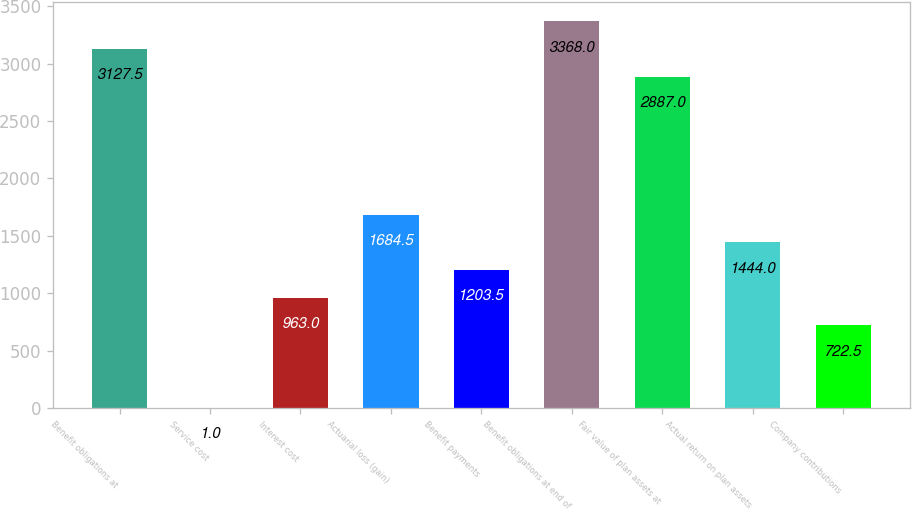Convert chart to OTSL. <chart><loc_0><loc_0><loc_500><loc_500><bar_chart><fcel>Benefit obligations at<fcel>Service cost<fcel>Interest cost<fcel>Actuarial loss (gain)<fcel>Benefit payments<fcel>Benefit obligations at end of<fcel>Fair value of plan assets at<fcel>Actual return on plan assets<fcel>Company contributions<nl><fcel>3127.5<fcel>1<fcel>963<fcel>1684.5<fcel>1203.5<fcel>3368<fcel>2887<fcel>1444<fcel>722.5<nl></chart> 